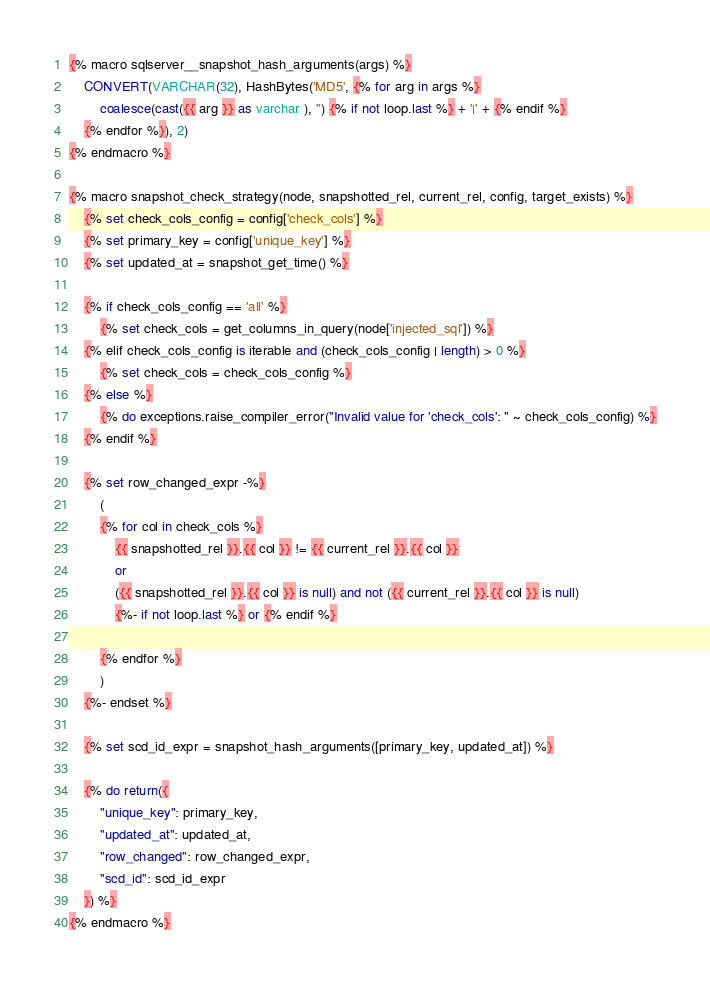<code> <loc_0><loc_0><loc_500><loc_500><_SQL_>{% macro sqlserver__snapshot_hash_arguments(args) %}
    CONVERT(VARCHAR(32), HashBytes('MD5', {% for arg in args %}
        coalesce(cast({{ arg }} as varchar ), '') {% if not loop.last %} + '|' + {% endif %}
    {% endfor %}), 2)
{% endmacro %}

{% macro snapshot_check_strategy(node, snapshotted_rel, current_rel, config, target_exists) %}
    {% set check_cols_config = config['check_cols'] %}
    {% set primary_key = config['unique_key'] %}
    {% set updated_at = snapshot_get_time() %}

    {% if check_cols_config == 'all' %}
        {% set check_cols = get_columns_in_query(node['injected_sql']) %}
    {% elif check_cols_config is iterable and (check_cols_config | length) > 0 %}
        {% set check_cols = check_cols_config %}
    {% else %}
        {% do exceptions.raise_compiler_error("Invalid value for 'check_cols': " ~ check_cols_config) %}
    {% endif %}

    {% set row_changed_expr -%}
        (
        {% for col in check_cols %}
            {{ snapshotted_rel }}.{{ col }} != {{ current_rel }}.{{ col }}
            or
            ({{ snapshotted_rel }}.{{ col }} is null) and not ({{ current_rel }}.{{ col }} is null)
            {%- if not loop.last %} or {% endif %}

        {% endfor %}
        )
    {%- endset %}

    {% set scd_id_expr = snapshot_hash_arguments([primary_key, updated_at]) %}

    {% do return({
        "unique_key": primary_key,
        "updated_at": updated_at,
        "row_changed": row_changed_expr,
        "scd_id": scd_id_expr
    }) %}
{% endmacro %}</code> 